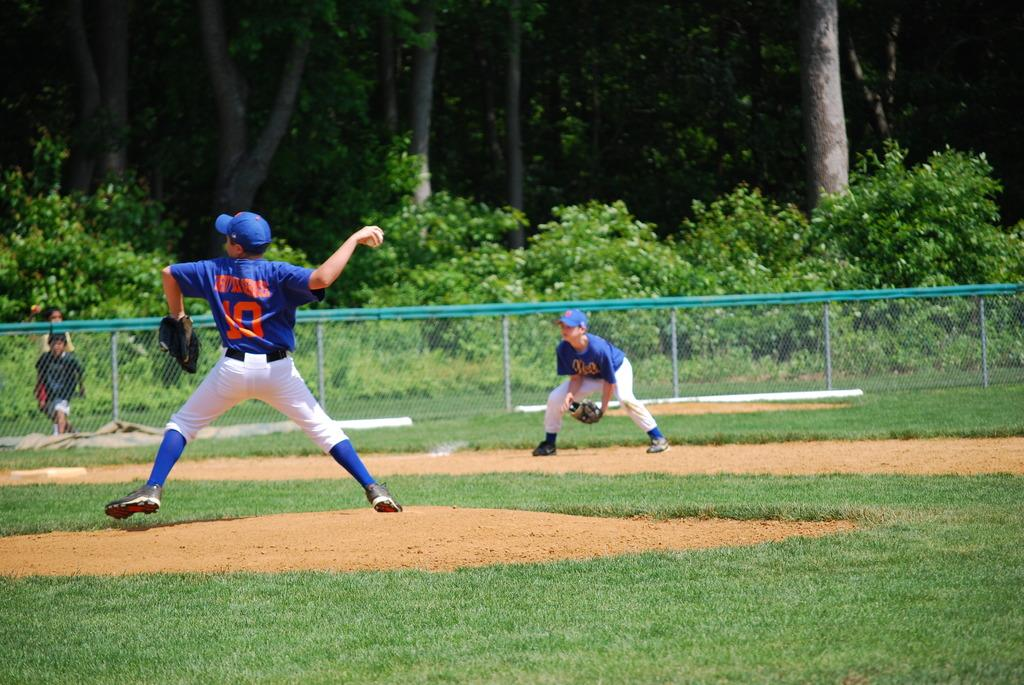Provide a one-sentence caption for the provided image. The number 10 player is at the mound throwing the baseball. 